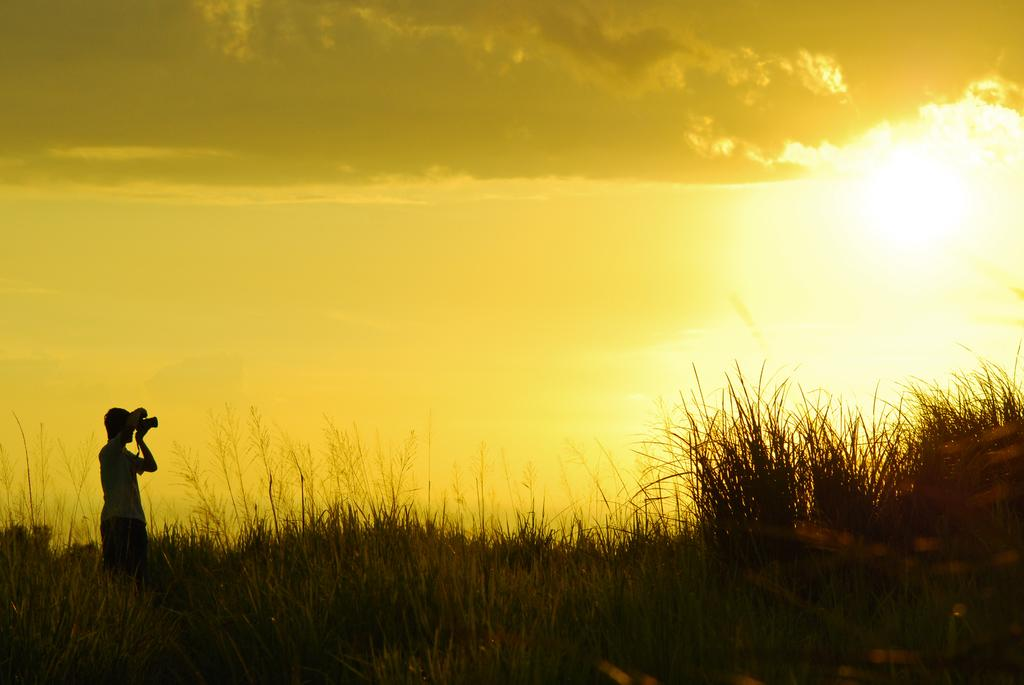What is the person in the image doing? The person is standing in the image and holding a camera. What can be seen on the ground in the image? There is grass visible in the image. What is visible in the background of the image? The sky is visible in the background of the image. What is the condition of the sky in the image? Clouds are present in the sky. What is the chance of rain in the image? The image does not provide any information about the likelihood of rain; it only shows clouds in the sky. 